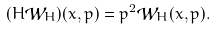Convert formula to latex. <formula><loc_0><loc_0><loc_500><loc_500>( H { \mathcal { W } } _ { H } ) ( x , p ) = p ^ { 2 } { \mathcal { W } } _ { H } ( x , p ) .</formula> 